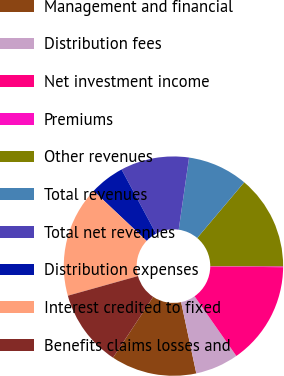Convert chart. <chart><loc_0><loc_0><loc_500><loc_500><pie_chart><fcel>Management and financial<fcel>Distribution fees<fcel>Net investment income<fcel>Premiums<fcel>Other revenues<fcel>Total revenues<fcel>Total net revenues<fcel>Distribution expenses<fcel>Interest credited to fixed<fcel>Benefits claims losses and<nl><fcel>12.62%<fcel>6.38%<fcel>15.12%<fcel>0.13%<fcel>13.87%<fcel>8.88%<fcel>10.12%<fcel>5.13%<fcel>16.37%<fcel>11.37%<nl></chart> 